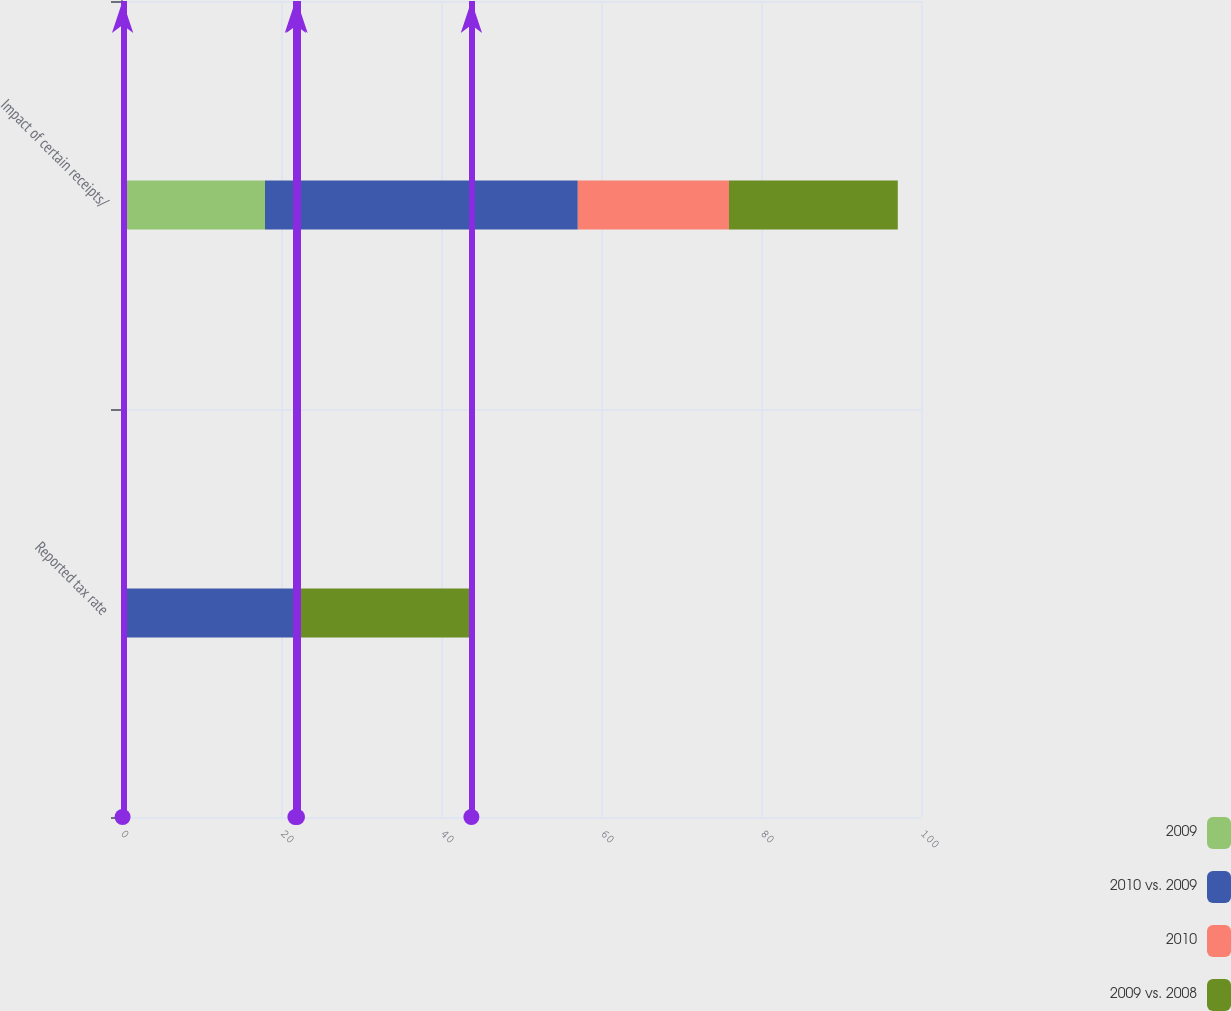Convert chart. <chart><loc_0><loc_0><loc_500><loc_500><stacked_bar_chart><ecel><fcel>Reported tax rate<fcel>Impact of certain receipts/<nl><fcel>2009<fcel>0.2<fcel>18<nl><fcel>2010 vs. 2009<fcel>21.6<fcel>39.1<nl><fcel>2010<fcel>0.2<fcel>18.9<nl><fcel>2009 vs. 2008<fcel>21.8<fcel>21.1<nl></chart> 